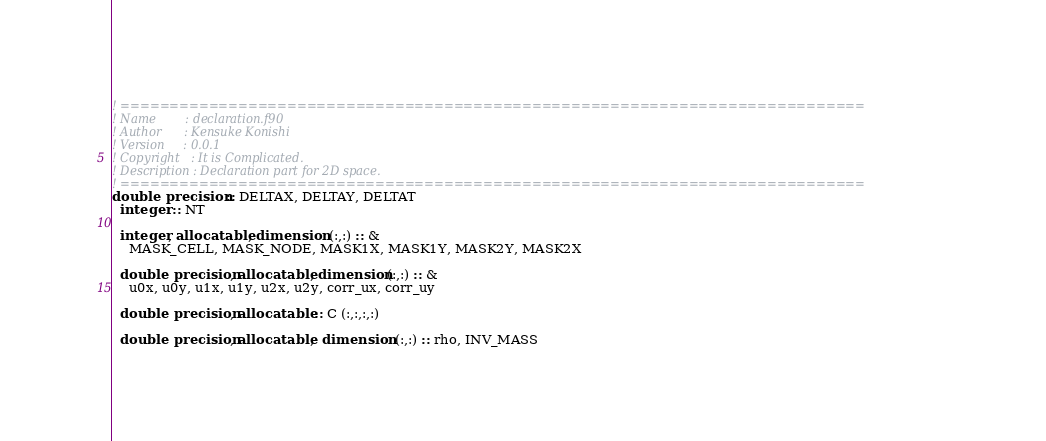Convert code to text. <code><loc_0><loc_0><loc_500><loc_500><_FORTRAN_>! ============================================================================
! Name        : declaration.f90
! Author      : Kensuke Konishi
! Version     : 0.0.1
! Copyright   : It is Complicated.
! Description : Declaration part for 2D space.
! ============================================================================
double precision :: DELTAX, DELTAY, DELTAT
  integer :: NT

  integer, allocatable, dimension (:,:) :: &
    MASK_CELL, MASK_NODE, MASK1X, MASK1Y, MASK2Y, MASK2X

  double precision, allocatable, dimension(:,:) :: &
    u0x, u0y, u1x, u1y, u2x, u2y, corr_ux, corr_uy

  double precision, allocatable :: C (:,:,:,:)

  double precision, allocatable,  dimension (:,:) :: rho, INV_MASS</code> 